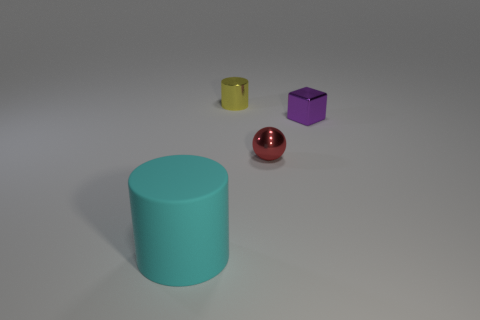Add 3 cubes. How many objects exist? 7 Subtract all blocks. How many objects are left? 3 Add 2 tiny purple shiny blocks. How many tiny purple shiny blocks are left? 3 Add 4 blue cylinders. How many blue cylinders exist? 4 Subtract 0 brown blocks. How many objects are left? 4 Subtract all tiny purple spheres. Subtract all cyan matte things. How many objects are left? 3 